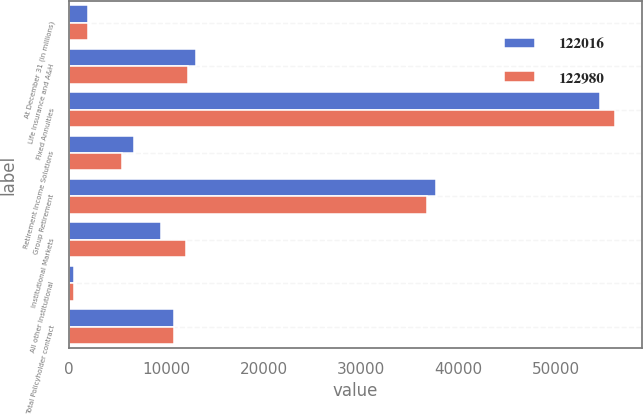Convert chart. <chart><loc_0><loc_0><loc_500><loc_500><stacked_bar_chart><ecel><fcel>At December 31 (in millions)<fcel>Life Insurance and A&H<fcel>Fixed Annuities<fcel>Retirement Income Solutions<fcel>Group Retirement<fcel>Institutional Markets<fcel>All other Institutional<fcel>Total Policyholder contract<nl><fcel>122016<fcel>2013<fcel>13081<fcel>54515<fcel>6729<fcel>37694<fcel>9433<fcel>564<fcel>10744.5<nl><fcel>122980<fcel>2012<fcel>12201<fcel>55985<fcel>5451<fcel>36778<fcel>12056<fcel>509<fcel>10744.5<nl></chart> 